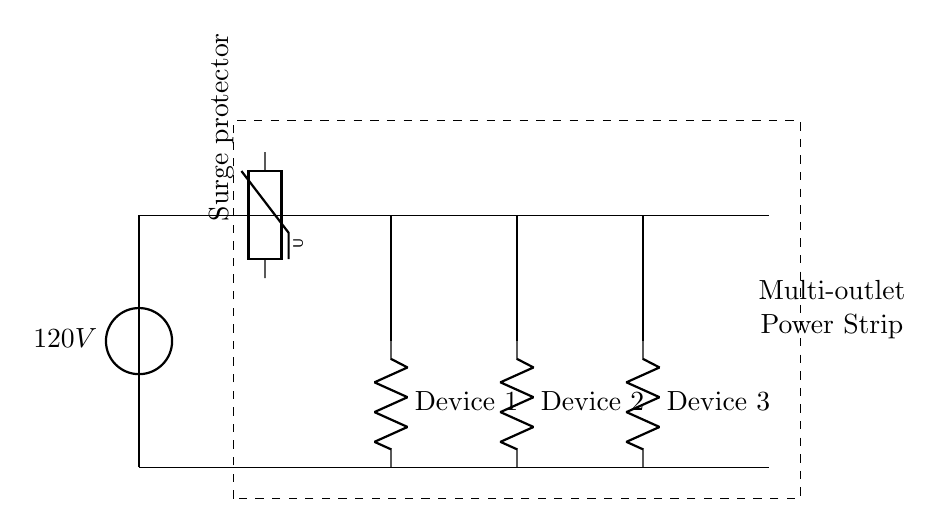What is the voltage source in this circuit? The circuit displays a voltage source marked as 120V, indicating the supplied voltage for the operation of the connected devices.
Answer: 120V What component provides surge protection? A component labeled as 'Surge protector' is indicated as a varistor in the diagram, which protects against voltage spikes or surges.
Answer: Surge protector How many devices are connected to the power strip? The diagram shows three outlets, each connected to a device labeled Device 1, Device 2, and Device 3, confirming three devices in total.
Answer: Three What type of circuit is depicted? The circuit is designed as a parallel circuit since each device is connected across the same voltage source without any series arrangement.
Answer: Parallel What does the dashed rectangle represent? The dashed rectangle encompasses the entire setup, indicating the physical outline of the multi-outlet power strip containing all components and devices.
Answer: Multi-outlet power strip If one device fails, what happens to the others? Because the devices are connected in parallel, if one device fails, the others remain operational as they do not share the same current path.
Answer: Remain operational 